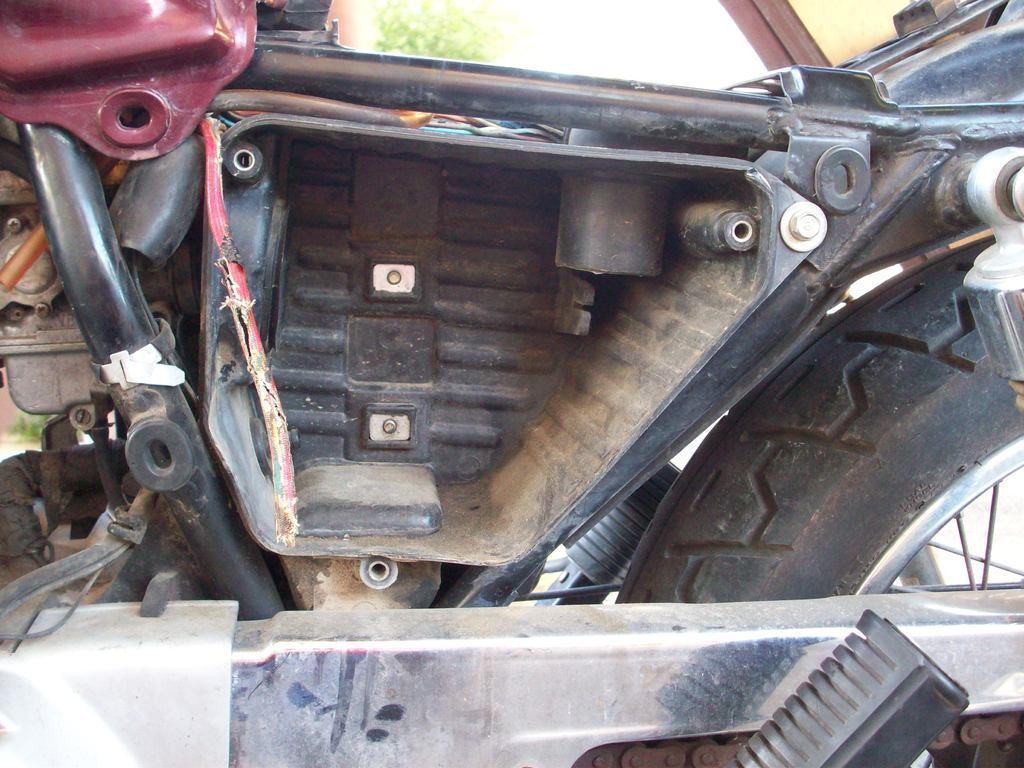Describe this image in one or two sentences. In this image, we can see an inside part of a vehicle and in the background, there is a tree. 